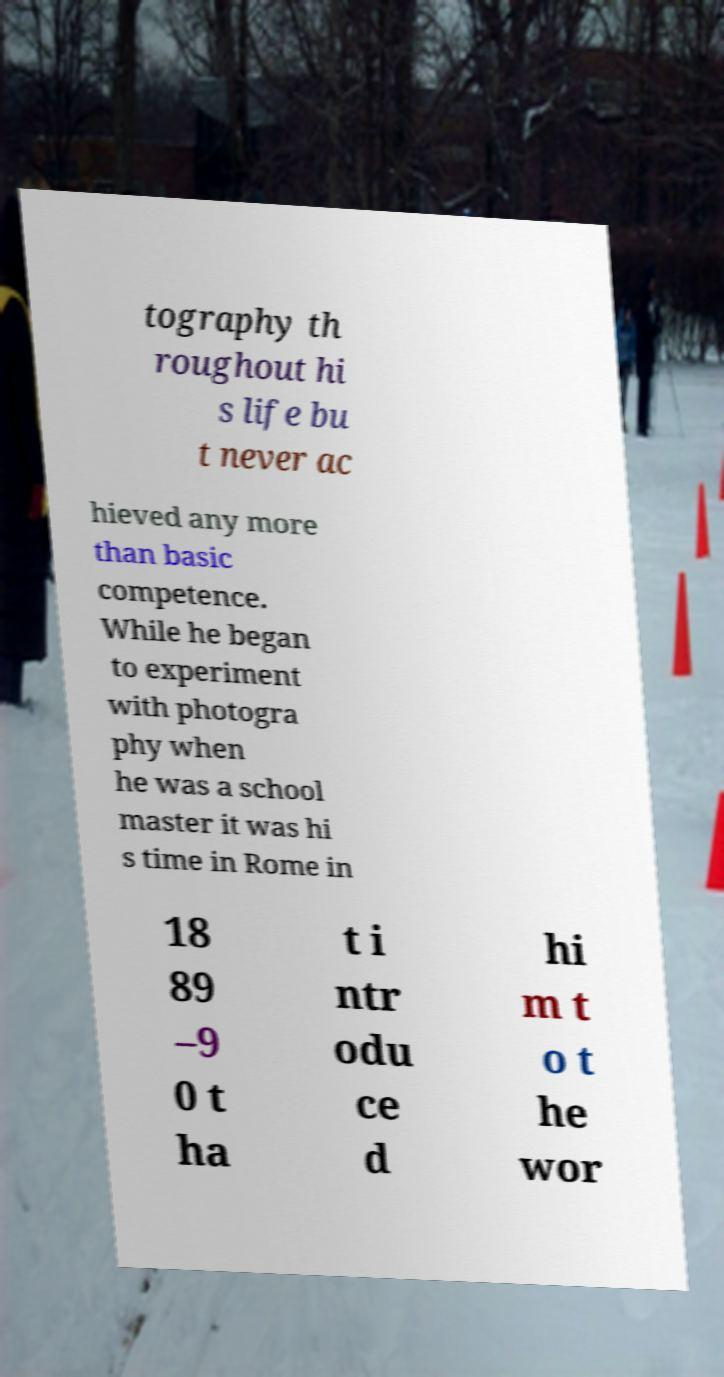Could you extract and type out the text from this image? tography th roughout hi s life bu t never ac hieved any more than basic competence. While he began to experiment with photogra phy when he was a school master it was hi s time in Rome in 18 89 –9 0 t ha t i ntr odu ce d hi m t o t he wor 